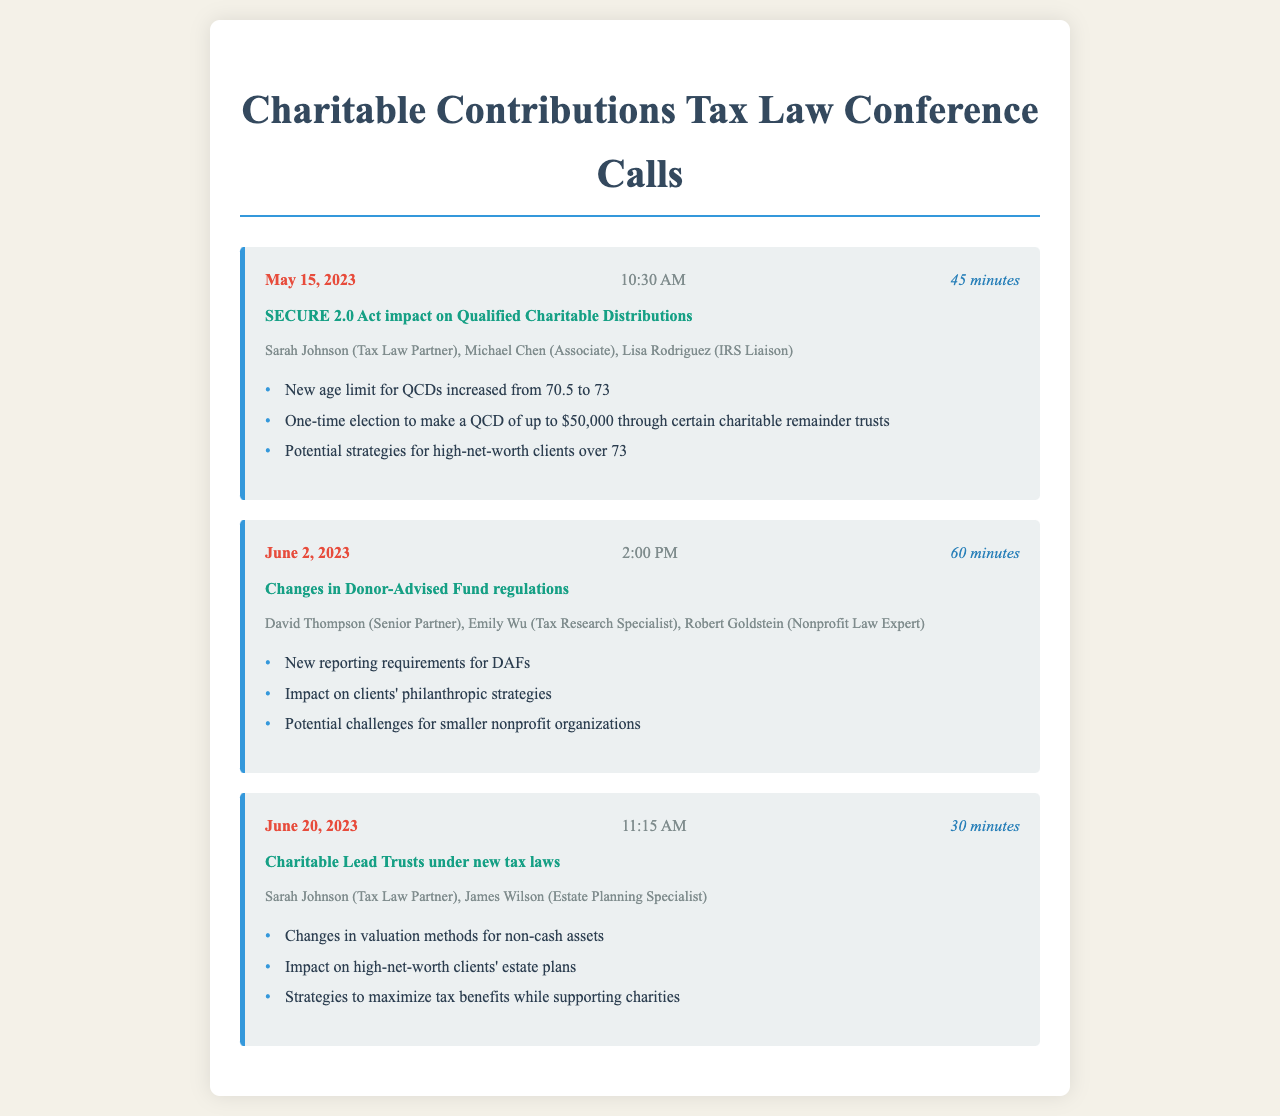What is the date of the first call? The date of the first call is listed in the call record, which is May 15, 2023.
Answer: May 15, 2023 Who participated in the second call? The participants in the second call are mentioned in the document, specifically David Thompson, Emily Wu, and Robert Goldstein.
Answer: David Thompson, Emily Wu, Robert Goldstein What is the main topic discussed in the last call? The last call's main topic is clearly stated in the call record under the "call-topic" section, which is "Charitable Lead Trusts under new tax laws."
Answer: Charitable Lead Trusts under new tax laws How long did the call on June 2, 2023, last? The duration of the call on June 2, 2023, is given in the document as part of the call record, which states it lasted 60 minutes.
Answer: 60 minutes What new age limit for Qualified Charitable Distributions was announced? The document specifies the new age limit for Qualified Charitable Distributions as discussed in the first call, which increased from 70.5 to 73.
Answer: 73 What are the new reporting requirements affecting? The new reporting requirements mentioned are affecting Donor-Advised Funds as discussed in the second call.
Answer: Donor-Advised Funds What was the focus of the key points in the call discussing Charitable Lead Trusts? The key points from the call discussing Charitable Lead Trusts focused on changes in valuation methods for non-cash assets, among other issues.
Answer: Changes in valuation methods for non-cash assets How many calls are recorded in the document? The document lists a total of three call records, each detailing a different topic and set of participants.
Answer: Three 